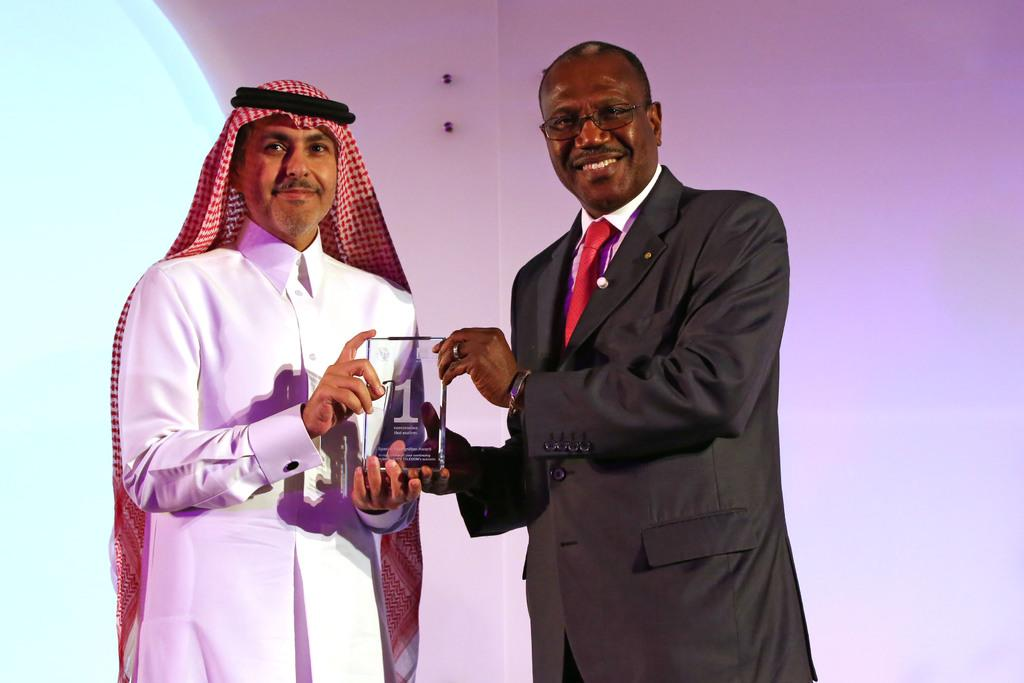How many people are present in the image? There are two persons in the image. What are the two persons doing in the image? The two persons are holding an object. What can be seen in the background of the image? There is a wall in the background of the image. What type of dock can be seen in the image? There is no dock present in the image. 